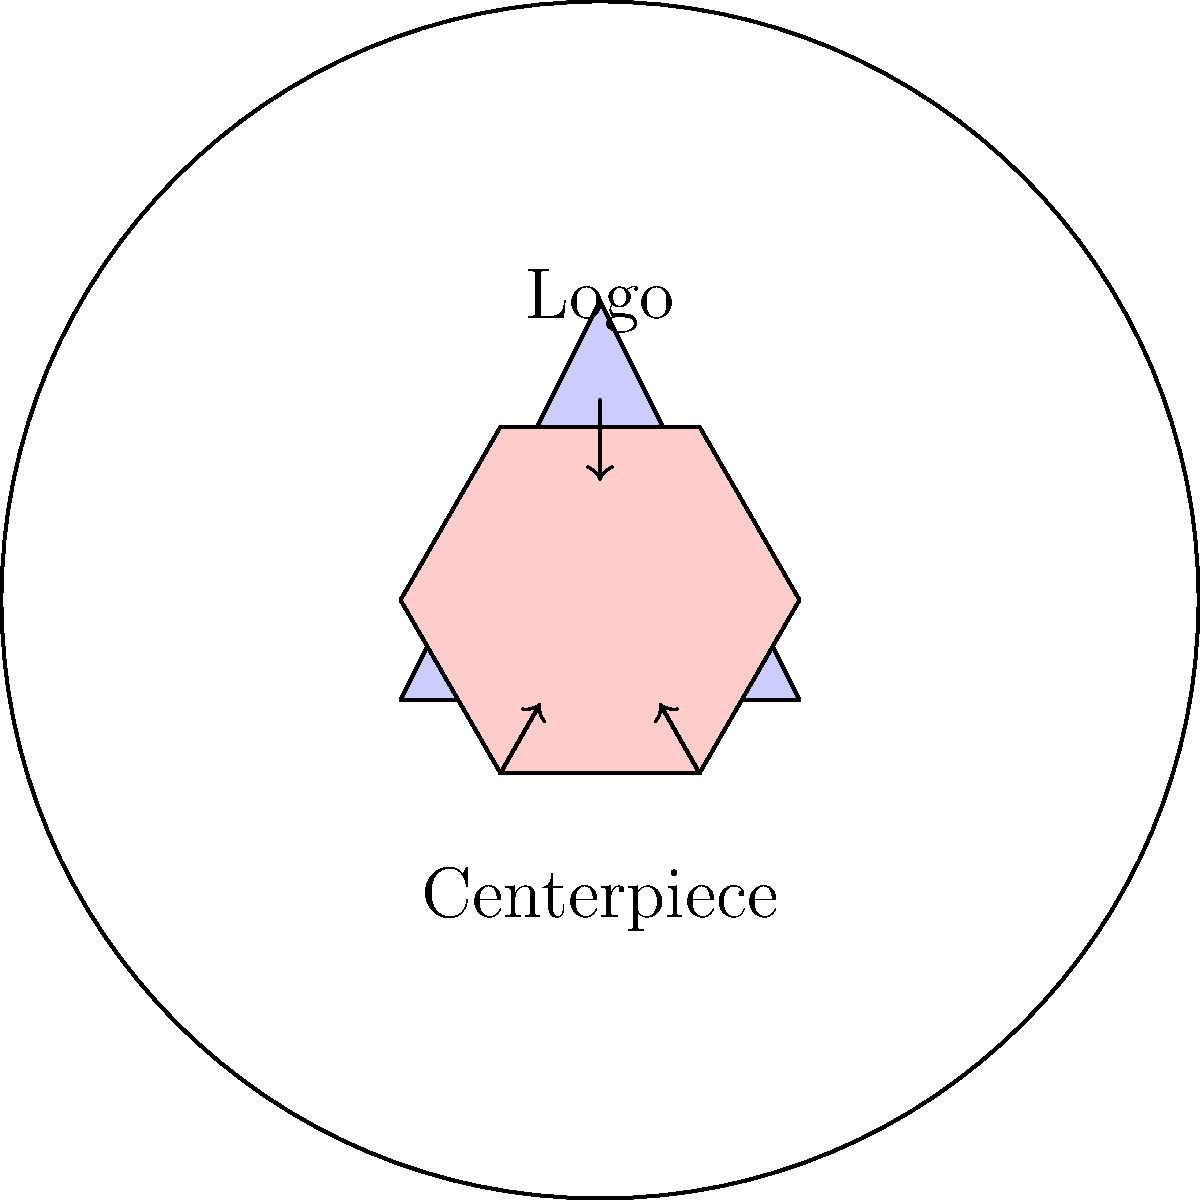As you plan the table decorations for your charity gala, you want to ensure the centerpieces complement the charity's logo. If the logo is an equilateral triangle and you decide to use hexagonal centerpieces, how many sides of the hexagon will be congruent to the sides of the triangular logo? Let's approach this step-by-step:

1. An equilateral triangle has three equal sides and three equal angles of 60°.

2. A regular hexagon has six equal sides and six equal angles of 120°.

3. To determine congruence, we need to compare the side lengths of the triangle and the hexagon.

4. In an equilateral triangle, if we divide it into six equal parts by drawing lines from the center to each vertex and midpoint of each side, we create six congruent 30-60-90 triangles.

5. The side of the equilateral triangle becomes the hypotenuse of two of these 30-60-90 triangles placed side by side.

6. In a regular hexagon, each side is equal to the radius of the circumscribed circle.

7. This radius is also equal to the side of the equilateral triangle that would be inscribed in the same circle.

8. Therefore, each side of the hexagon is congruent to each side of the equilateral triangle.

9. Since the hexagon has six sides, and each of these is congruent to each side of the triangle, all six sides of the hexagon are congruent to the sides of the triangular logo.
Answer: 6 